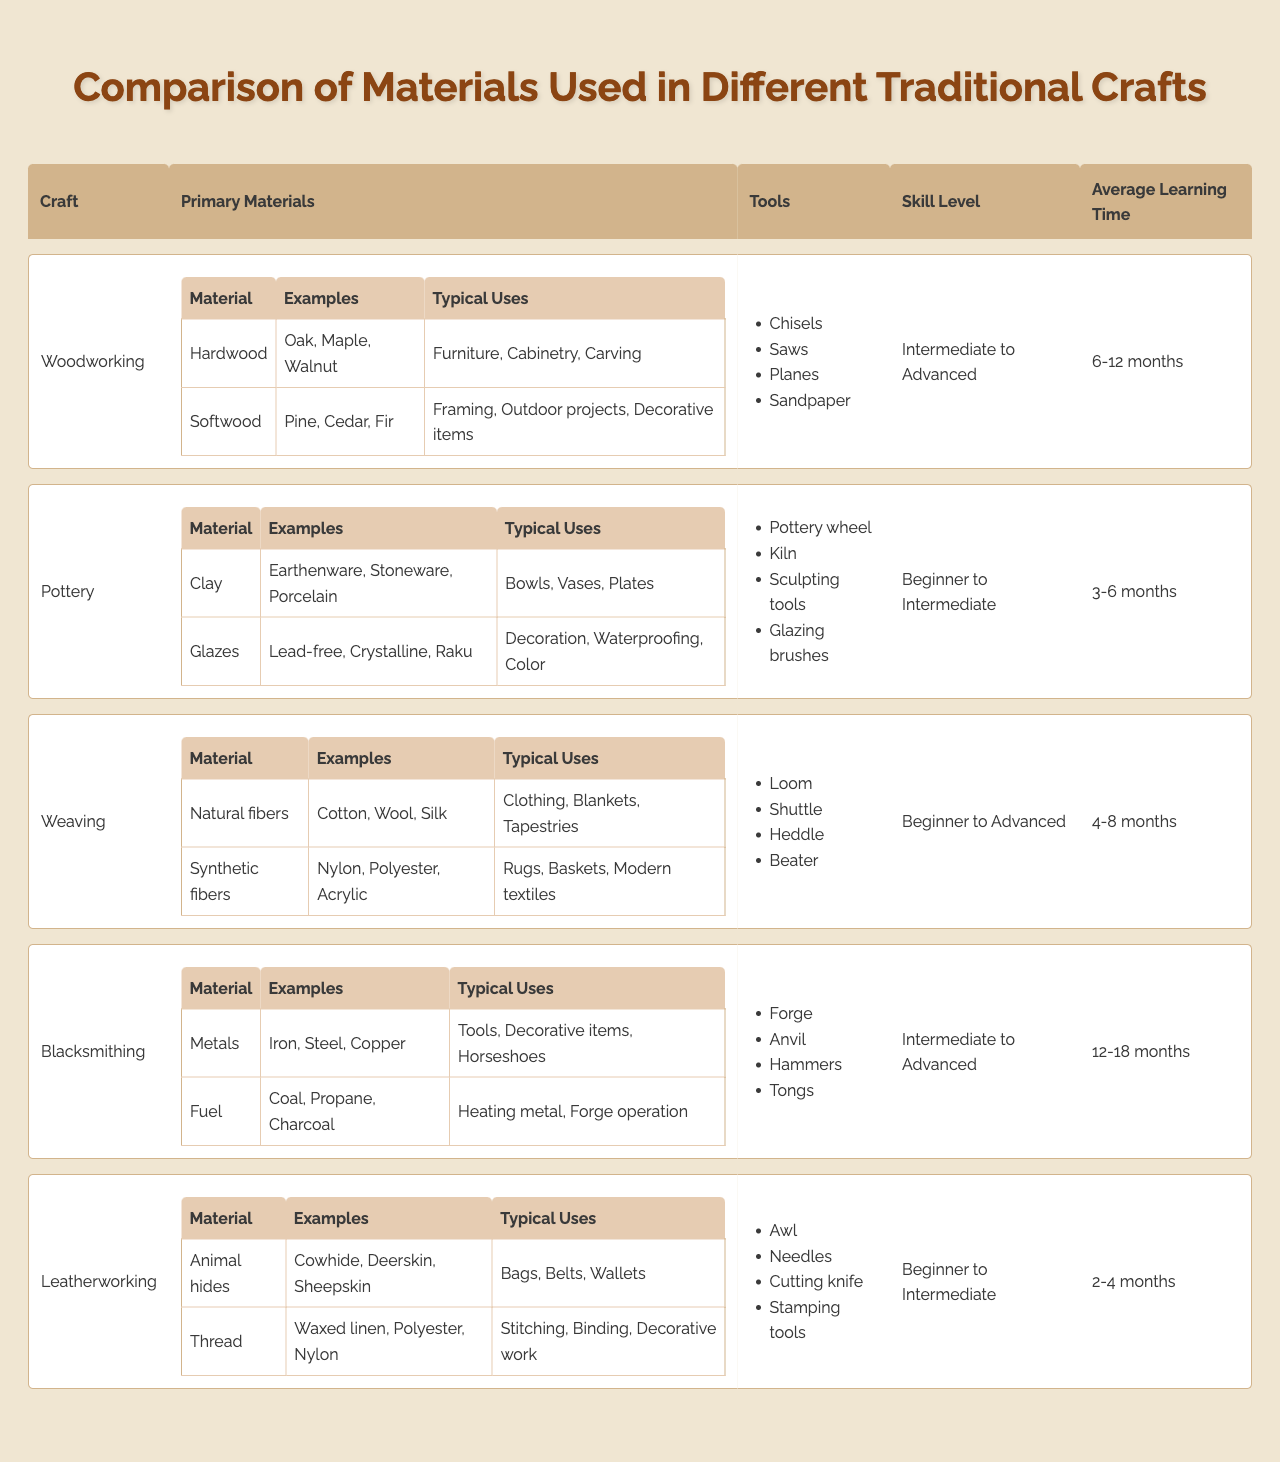What materials are used in Pottery? The table indicates that the primary materials used in Pottery are Clay and Glazes. Additionally, it lists examples and typical uses for each material.
Answer: Clay and Glazes Which craft has the longest average learning time? By examining the average learning time column, Blacksmithing has an average learning time of 12-18 months, which is longer than the other crafts listed.
Answer: Blacksmithing Does Leatherworking require advanced skills? The skill level for Leatherworking is categorized as "Beginner to Intermediate," which means it does not require advanced skills.
Answer: No What is the typical use for hardwood in Woodworking? The typical uses for hardwoods such as Oak and Walnut in Woodworking include Furniture, Cabinetry, and Carving.
Answer: Furniture, Cabinetry, Carving How many different primary materials are listed for Weaving? In the table, Weaving has two primary materials listed: Natural fibers and Synthetic fibers.
Answer: Two Is Softwood used for decorative items in Woodworking? Yes, the typical uses for Softwood in Woodworking include decorative items, as indicated in the examples provided in the table.
Answer: Yes What type of tools do all crafts have in common? While examining the tools listed, no tool is common across all crafts, as each craft has its specific set of tools.
Answer: None How does the average learning time for Pottery compare to Leatherworking? Pottery has an average learning time of 3-6 months, while Leatherworking takes 2-4 months on average. Pottery takes longer.
Answer: Pottery takes longer Which craft involves the use of metals and what are two examples? Blacksmithing involves the use of metals, with examples including Iron and Steel.
Answer: Blacksmithing; Iron, Steel For Weaving, which fiber type is generally natural? The primary materials for Weaving include Natural fibers like Cotton, Wool, and Silk; these are generally natural fibers, as indicated in the table.
Answer: Natural fibers What are the typical uses of clay in Pottery? The typical uses for clay in Pottery include Bowls, Vases, and Plates as outlined in the examples provided in the table.
Answer: Bowls, Vases, Plates 